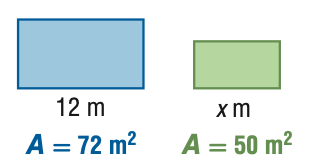Question: For the pair of similar figures, use the given areas to find the scale factor of the blue to the green figure.
Choices:
A. \frac { 25 } { 36 }
B. \frac { 5 } { 6 }
C. \frac { 6 } { 5 }
D. \frac { 36 } { 25 }
Answer with the letter. Answer: C 